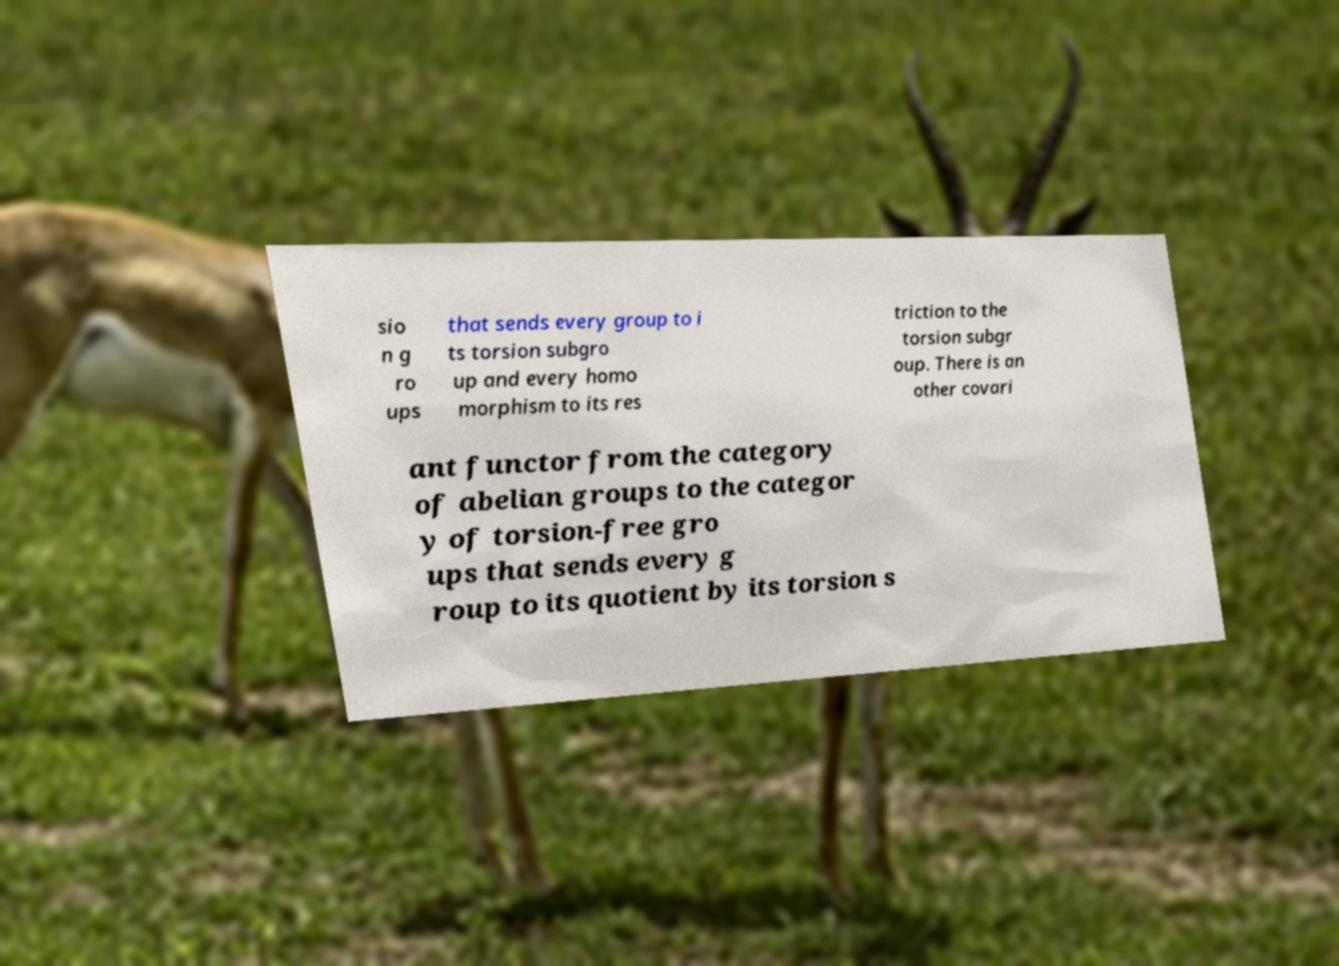Could you extract and type out the text from this image? sio n g ro ups that sends every group to i ts torsion subgro up and every homo morphism to its res triction to the torsion subgr oup. There is an other covari ant functor from the category of abelian groups to the categor y of torsion-free gro ups that sends every g roup to its quotient by its torsion s 